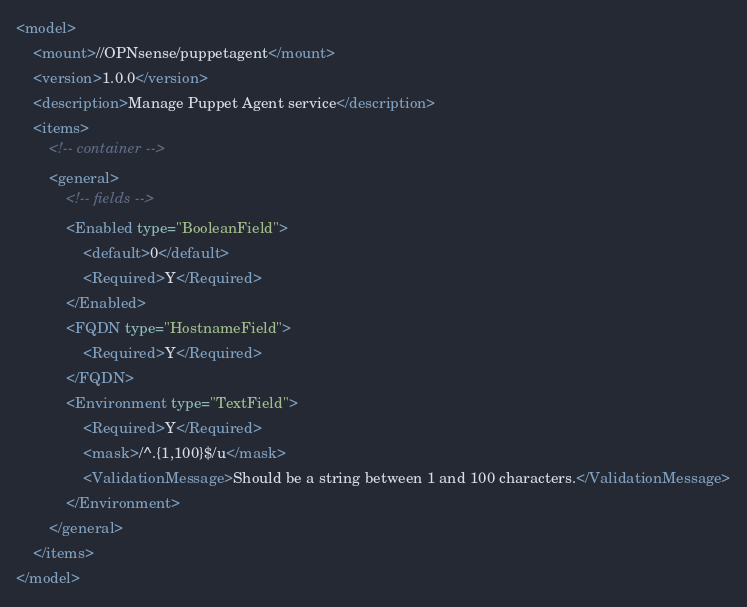Convert code to text. <code><loc_0><loc_0><loc_500><loc_500><_XML_><model>
    <mount>//OPNsense/puppetagent</mount>
    <version>1.0.0</version>
    <description>Manage Puppet Agent service</description>
    <items>
        <!-- container -->
        <general>
            <!-- fields -->
            <Enabled type="BooleanField">
                <default>0</default>
                <Required>Y</Required>
            </Enabled>
            <FQDN type="HostnameField">
                <Required>Y</Required>
            </FQDN>
            <Environment type="TextField">
                <Required>Y</Required>
                <mask>/^.{1,100}$/u</mask>
                <ValidationMessage>Should be a string between 1 and 100 characters.</ValidationMessage>
            </Environment>
        </general>
    </items>
</model>
</code> 